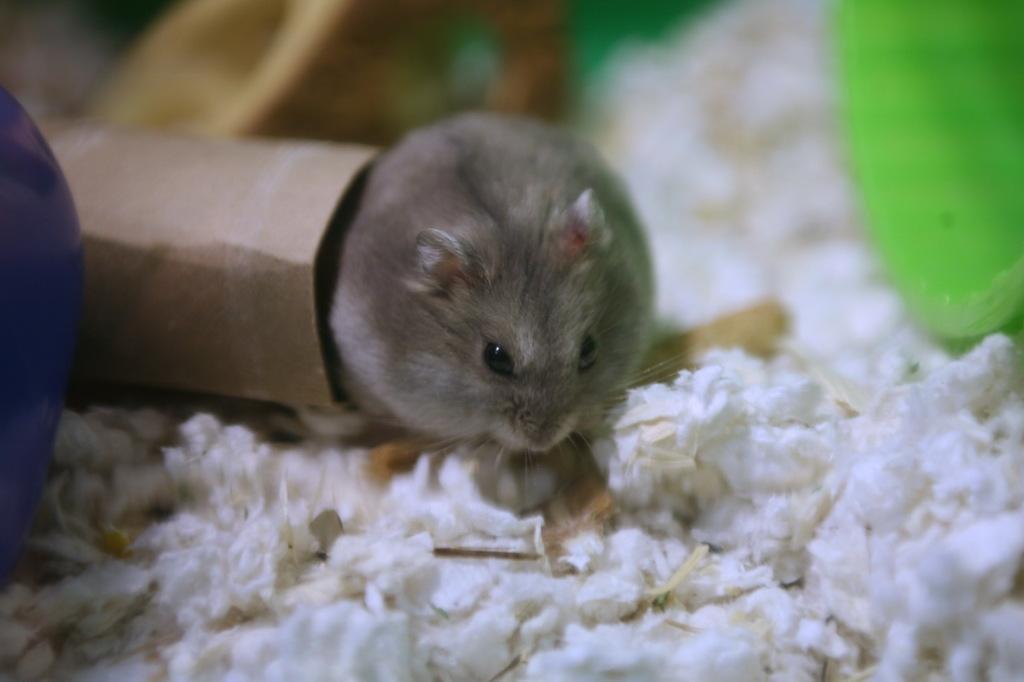How would you summarize this image in a sentence or two? This is a picture of a mouse. Right side of the mouse one paper is there. Bottom of the image some white color object is present. 